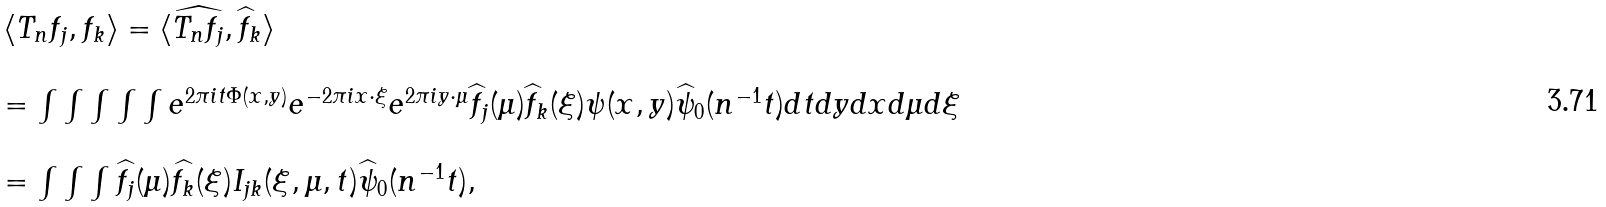<formula> <loc_0><loc_0><loc_500><loc_500>\begin{array} { l l } & \langle T _ { n } f _ { j } , f _ { k } \rangle = \langle \widehat { T _ { n } f _ { j } } , \widehat { f } _ { k } \rangle \\ \\ & = \int \int \int \int \int e ^ { 2 \pi i t \Phi ( x , y ) } e ^ { - 2 \pi i x \cdot \xi } e ^ { 2 \pi i y \cdot \mu } \widehat { f } _ { j } ( \mu ) \widehat { f } _ { k } ( \xi ) \psi ( x , y ) \widehat { \psi } _ { 0 } ( n ^ { - 1 } t ) d t d y d x d \mu d \xi \\ \\ & = \int \int \int \widehat { f _ { j } } ( \mu ) \widehat { f _ { k } } ( \xi ) I _ { j k } ( \xi , \mu , t ) \widehat { \psi } _ { 0 } ( n ^ { - 1 } t ) , \end{array}</formula> 